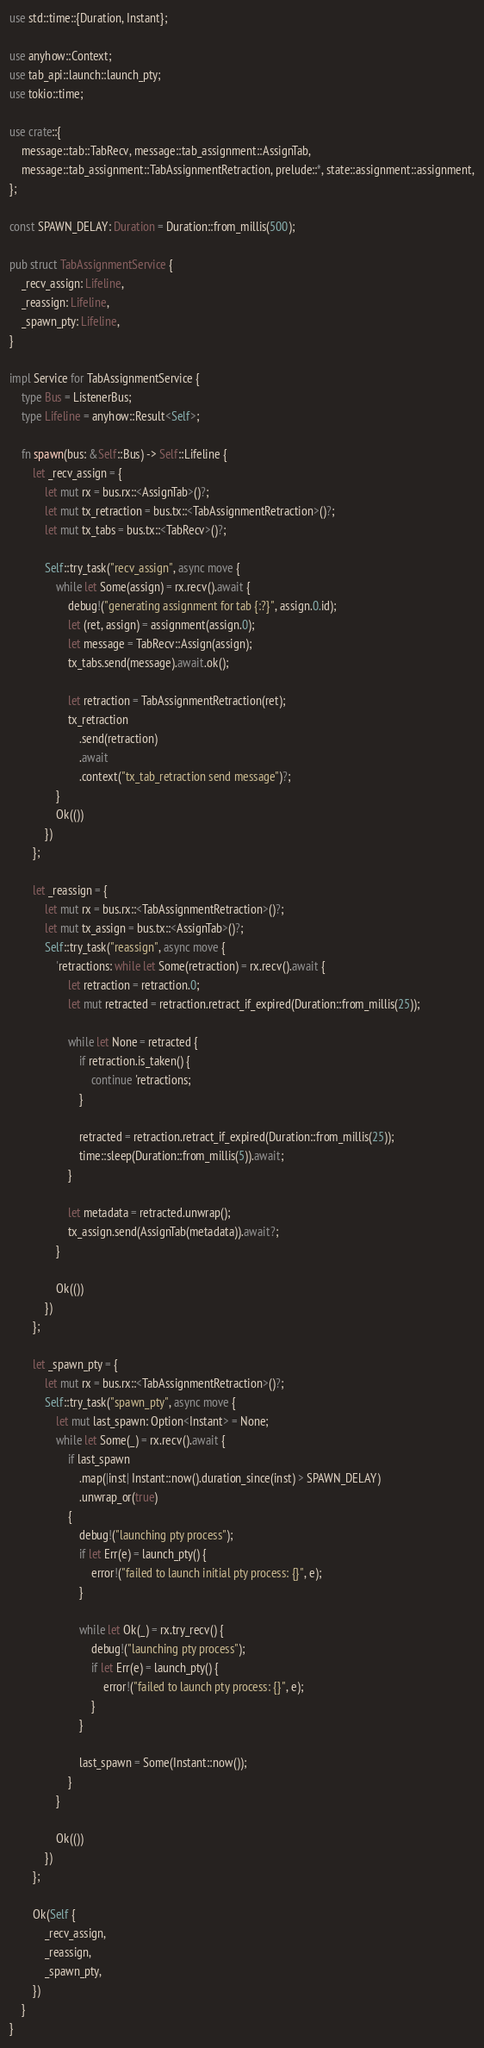<code> <loc_0><loc_0><loc_500><loc_500><_Rust_>use std::time::{Duration, Instant};

use anyhow::Context;
use tab_api::launch::launch_pty;
use tokio::time;

use crate::{
    message::tab::TabRecv, message::tab_assignment::AssignTab,
    message::tab_assignment::TabAssignmentRetraction, prelude::*, state::assignment::assignment,
};

const SPAWN_DELAY: Duration = Duration::from_millis(500);

pub struct TabAssignmentService {
    _recv_assign: Lifeline,
    _reassign: Lifeline,
    _spawn_pty: Lifeline,
}

impl Service for TabAssignmentService {
    type Bus = ListenerBus;
    type Lifeline = anyhow::Result<Self>;

    fn spawn(bus: &Self::Bus) -> Self::Lifeline {
        let _recv_assign = {
            let mut rx = bus.rx::<AssignTab>()?;
            let mut tx_retraction = bus.tx::<TabAssignmentRetraction>()?;
            let mut tx_tabs = bus.tx::<TabRecv>()?;

            Self::try_task("recv_assign", async move {
                while let Some(assign) = rx.recv().await {
                    debug!("generating assignment for tab {:?}", assign.0.id);
                    let (ret, assign) = assignment(assign.0);
                    let message = TabRecv::Assign(assign);
                    tx_tabs.send(message).await.ok();

                    let retraction = TabAssignmentRetraction(ret);
                    tx_retraction
                        .send(retraction)
                        .await
                        .context("tx_tab_retraction send message")?;
                }
                Ok(())
            })
        };

        let _reassign = {
            let mut rx = bus.rx::<TabAssignmentRetraction>()?;
            let mut tx_assign = bus.tx::<AssignTab>()?;
            Self::try_task("reassign", async move {
                'retractions: while let Some(retraction) = rx.recv().await {
                    let retraction = retraction.0;
                    let mut retracted = retraction.retract_if_expired(Duration::from_millis(25));

                    while let None = retracted {
                        if retraction.is_taken() {
                            continue 'retractions;
                        }

                        retracted = retraction.retract_if_expired(Duration::from_millis(25));
                        time::sleep(Duration::from_millis(5)).await;
                    }

                    let metadata = retracted.unwrap();
                    tx_assign.send(AssignTab(metadata)).await?;
                }

                Ok(())
            })
        };

        let _spawn_pty = {
            let mut rx = bus.rx::<TabAssignmentRetraction>()?;
            Self::try_task("spawn_pty", async move {
                let mut last_spawn: Option<Instant> = None;
                while let Some(_) = rx.recv().await {
                    if last_spawn
                        .map(|inst| Instant::now().duration_since(inst) > SPAWN_DELAY)
                        .unwrap_or(true)
                    {
                        debug!("launching pty process");
                        if let Err(e) = launch_pty() {
                            error!("failed to launch initial pty process: {}", e);
                        }

                        while let Ok(_) = rx.try_recv() {
                            debug!("launching pty process");
                            if let Err(e) = launch_pty() {
                                error!("failed to launch pty process: {}", e);
                            }
                        }

                        last_spawn = Some(Instant::now());
                    }
                }

                Ok(())
            })
        };

        Ok(Self {
            _recv_assign,
            _reassign,
            _spawn_pty,
        })
    }
}
</code> 